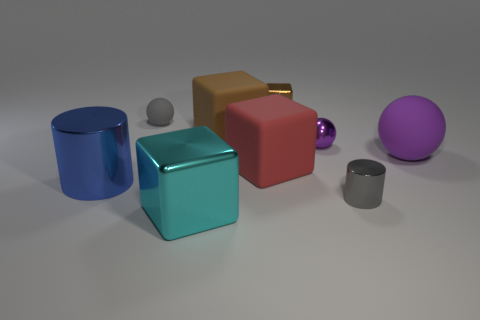Subtract all small metal balls. How many balls are left? 2 Add 1 small purple balls. How many objects exist? 10 Subtract all gray spheres. How many spheres are left? 2 Subtract 3 blocks. How many blocks are left? 1 Subtract all small brown matte cylinders. Subtract all big metallic things. How many objects are left? 7 Add 5 brown rubber things. How many brown rubber things are left? 6 Add 5 small green spheres. How many small green spheres exist? 5 Subtract 0 brown cylinders. How many objects are left? 9 Subtract all blocks. How many objects are left? 5 Subtract all purple cylinders. Subtract all gray balls. How many cylinders are left? 2 